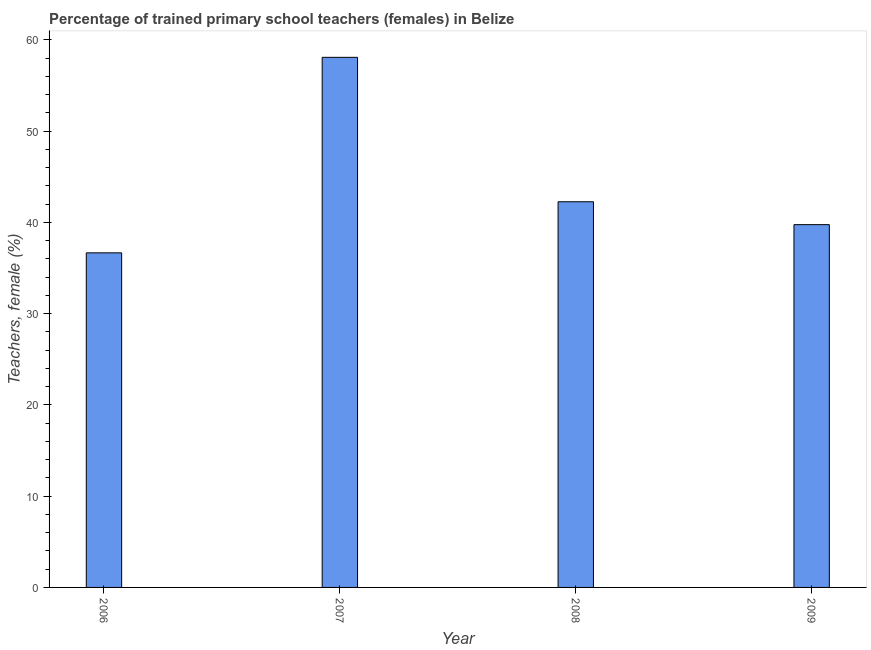Does the graph contain grids?
Your response must be concise. No. What is the title of the graph?
Offer a terse response. Percentage of trained primary school teachers (females) in Belize. What is the label or title of the Y-axis?
Make the answer very short. Teachers, female (%). What is the percentage of trained female teachers in 2006?
Your answer should be compact. 36.66. Across all years, what is the maximum percentage of trained female teachers?
Offer a very short reply. 58.08. Across all years, what is the minimum percentage of trained female teachers?
Offer a very short reply. 36.66. In which year was the percentage of trained female teachers maximum?
Provide a succinct answer. 2007. What is the sum of the percentage of trained female teachers?
Your answer should be very brief. 176.76. What is the difference between the percentage of trained female teachers in 2007 and 2008?
Make the answer very short. 15.82. What is the average percentage of trained female teachers per year?
Make the answer very short. 44.19. What is the median percentage of trained female teachers?
Provide a short and direct response. 41.01. What is the ratio of the percentage of trained female teachers in 2006 to that in 2007?
Offer a very short reply. 0.63. Is the difference between the percentage of trained female teachers in 2007 and 2009 greater than the difference between any two years?
Offer a terse response. No. What is the difference between the highest and the second highest percentage of trained female teachers?
Keep it short and to the point. 15.82. What is the difference between the highest and the lowest percentage of trained female teachers?
Make the answer very short. 21.42. In how many years, is the percentage of trained female teachers greater than the average percentage of trained female teachers taken over all years?
Your answer should be compact. 1. What is the Teachers, female (%) of 2006?
Offer a very short reply. 36.66. What is the Teachers, female (%) of 2007?
Make the answer very short. 58.08. What is the Teachers, female (%) of 2008?
Make the answer very short. 42.26. What is the Teachers, female (%) of 2009?
Offer a terse response. 39.75. What is the difference between the Teachers, female (%) in 2006 and 2007?
Provide a short and direct response. -21.42. What is the difference between the Teachers, female (%) in 2006 and 2008?
Provide a succinct answer. -5.6. What is the difference between the Teachers, female (%) in 2006 and 2009?
Ensure brevity in your answer.  -3.09. What is the difference between the Teachers, female (%) in 2007 and 2008?
Provide a short and direct response. 15.82. What is the difference between the Teachers, female (%) in 2007 and 2009?
Provide a short and direct response. 18.33. What is the difference between the Teachers, female (%) in 2008 and 2009?
Your response must be concise. 2.51. What is the ratio of the Teachers, female (%) in 2006 to that in 2007?
Your answer should be very brief. 0.63. What is the ratio of the Teachers, female (%) in 2006 to that in 2008?
Make the answer very short. 0.87. What is the ratio of the Teachers, female (%) in 2006 to that in 2009?
Your answer should be compact. 0.92. What is the ratio of the Teachers, female (%) in 2007 to that in 2008?
Your response must be concise. 1.37. What is the ratio of the Teachers, female (%) in 2007 to that in 2009?
Your answer should be compact. 1.46. What is the ratio of the Teachers, female (%) in 2008 to that in 2009?
Provide a short and direct response. 1.06. 